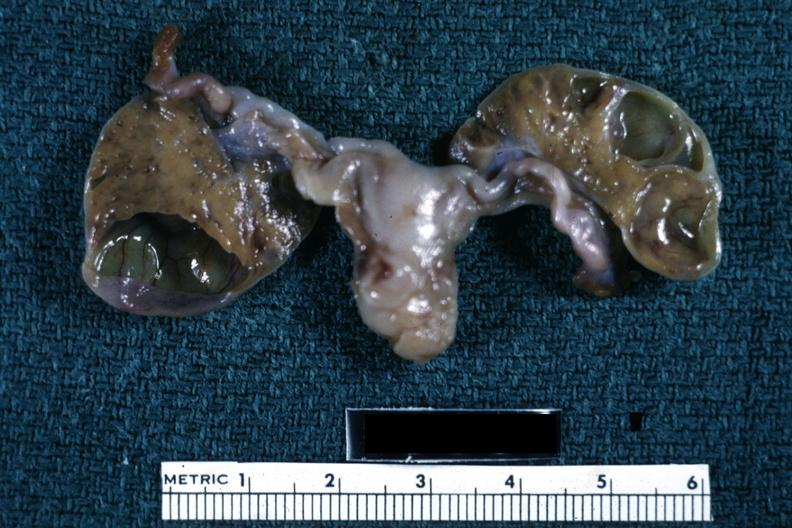what is present?
Answer the question using a single word or phrase. Female reproductive 